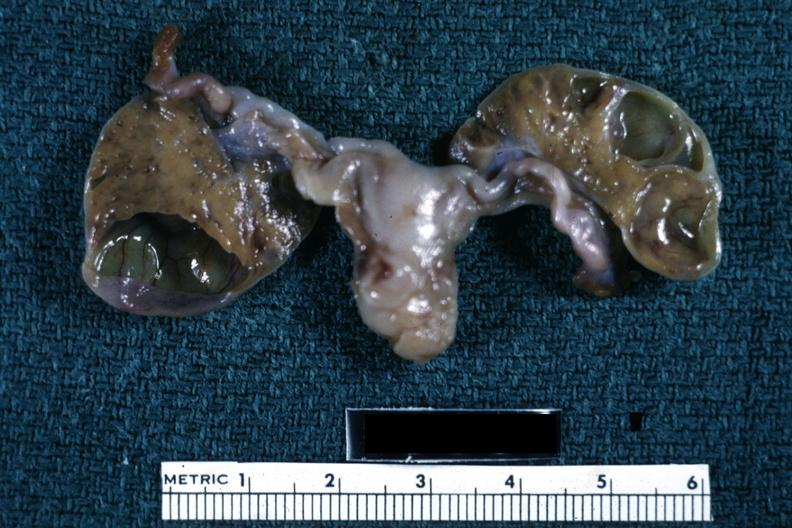what is present?
Answer the question using a single word or phrase. Female reproductive 